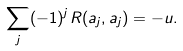Convert formula to latex. <formula><loc_0><loc_0><loc_500><loc_500>\sum _ { j } ( - 1 ) ^ { j } R ( a _ { j } , a _ { j } ) = - u .</formula> 